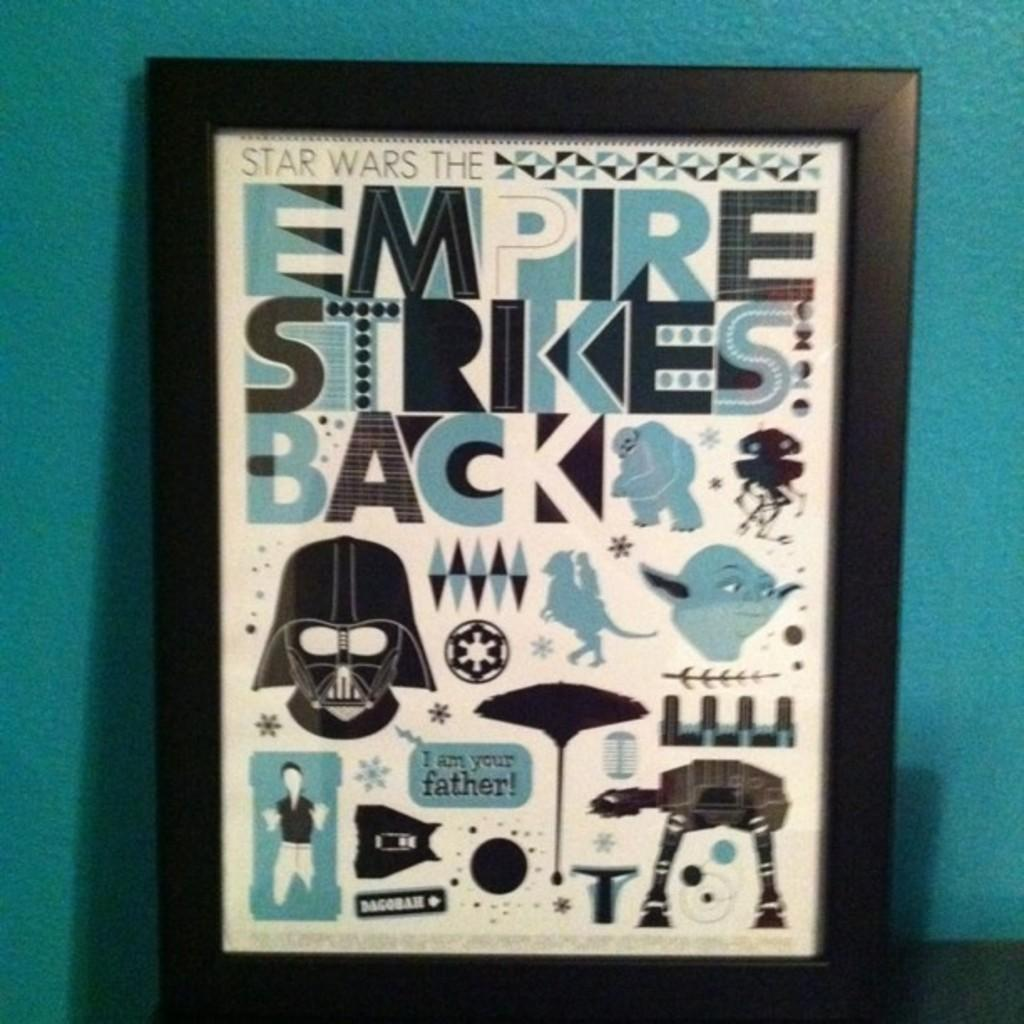What object is present in the image that typically holds photos or other images? There is a photo frame in the image. What types of content can be found within the photo frame? The photo frame contains text, logos, and pictures. What color is the wall visible in the background of the image? There is a blue wall in the background of the image. Can you see a rifle leaning against the blue wall in the image? No, there is no rifle present in the image. 